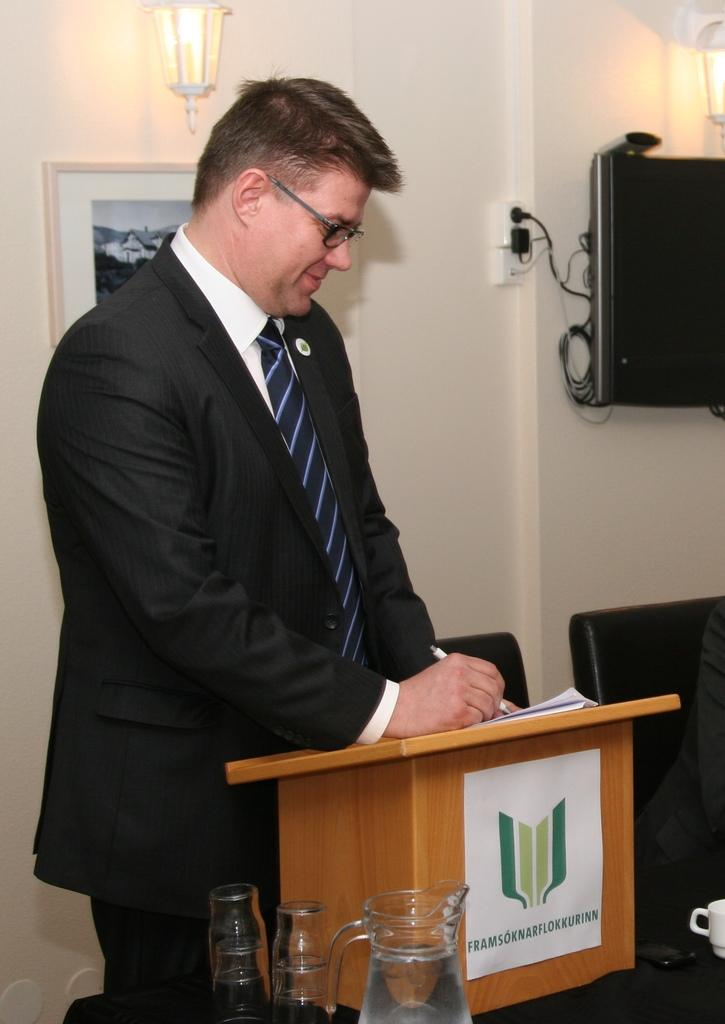What is the color of the wall in the image? The wall in the image is white. What can be seen hanging on the wall? There is a frame in the image. What is the source of light in the image? There is a light in the image. What electronic device is present in the image? There is a television in the image. What objects are used for drinking in the image? There are glasses in the image. Who is present in the image? There is a man standing in the image. What type of animals can be seen at the zoo in the image? There is no zoo present in the image; it features a white wall, a frame, a light, a television, glasses, and a man standing. What letter is being written by the man in the image? There is no indication that the man is writing a letter or any text in the image. 